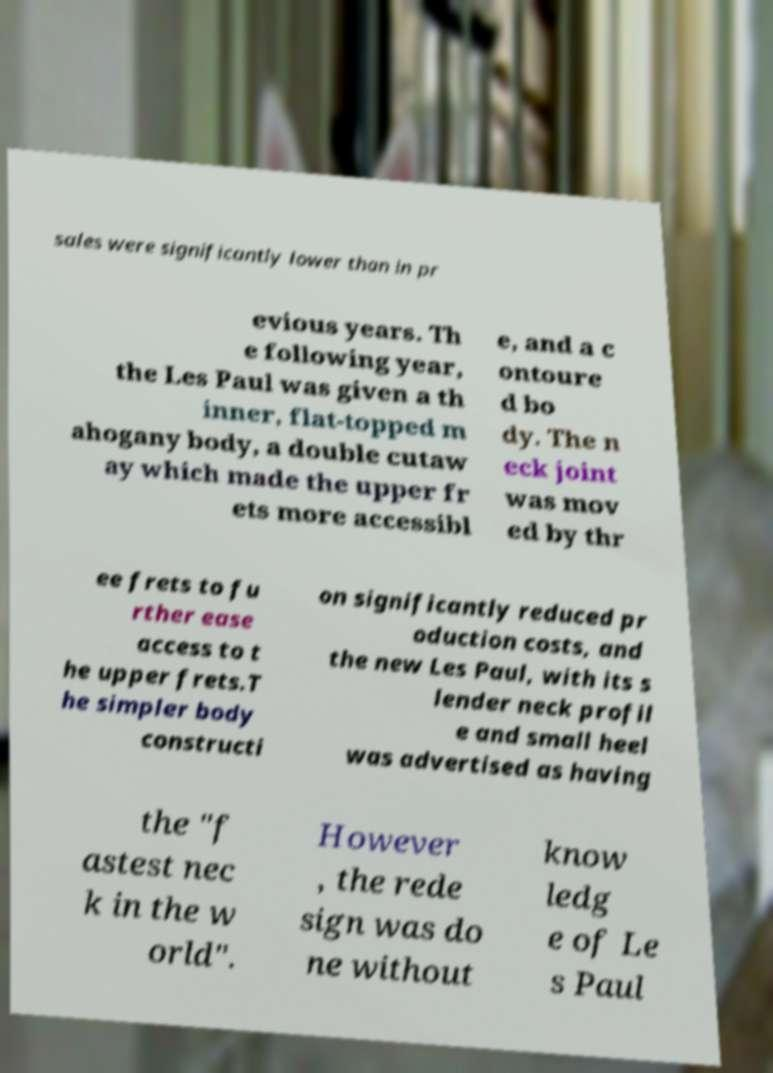There's text embedded in this image that I need extracted. Can you transcribe it verbatim? sales were significantly lower than in pr evious years. Th e following year, the Les Paul was given a th inner, flat-topped m ahogany body, a double cutaw ay which made the upper fr ets more accessibl e, and a c ontoure d bo dy. The n eck joint was mov ed by thr ee frets to fu rther ease access to t he upper frets.T he simpler body constructi on significantly reduced pr oduction costs, and the new Les Paul, with its s lender neck profil e and small heel was advertised as having the "f astest nec k in the w orld". However , the rede sign was do ne without know ledg e of Le s Paul 